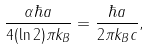<formula> <loc_0><loc_0><loc_500><loc_500>\frac { \alpha \hbar { a } } { 4 ( \ln 2 ) \pi k _ { B } } = \frac { \hbar { a } } { 2 \pi k _ { B } c } ,</formula> 